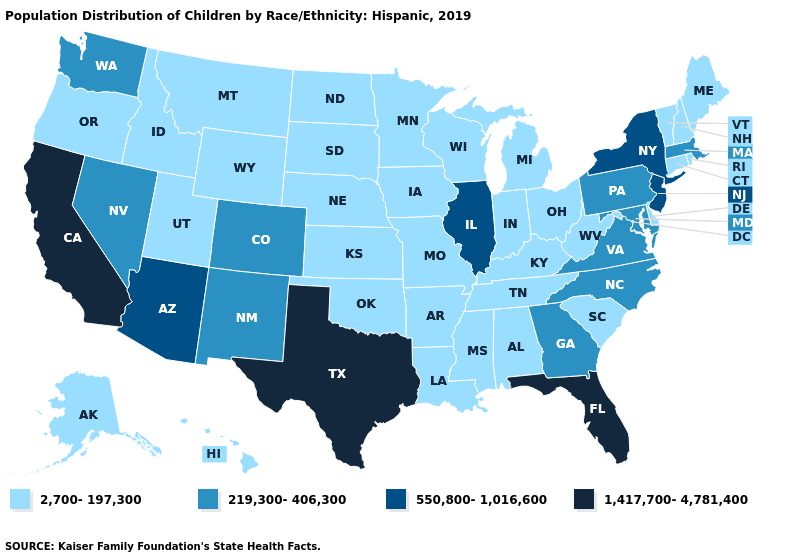Which states have the lowest value in the USA?
Write a very short answer. Alabama, Alaska, Arkansas, Connecticut, Delaware, Hawaii, Idaho, Indiana, Iowa, Kansas, Kentucky, Louisiana, Maine, Michigan, Minnesota, Mississippi, Missouri, Montana, Nebraska, New Hampshire, North Dakota, Ohio, Oklahoma, Oregon, Rhode Island, South Carolina, South Dakota, Tennessee, Utah, Vermont, West Virginia, Wisconsin, Wyoming. Does Missouri have the highest value in the MidWest?
Write a very short answer. No. What is the value of Idaho?
Write a very short answer. 2,700-197,300. Does Florida have the highest value in the USA?
Write a very short answer. Yes. What is the highest value in states that border New Mexico?
Quick response, please. 1,417,700-4,781,400. Among the states that border Virginia , does North Carolina have the highest value?
Write a very short answer. Yes. Does Colorado have a higher value than Missouri?
Be succinct. Yes. Among the states that border Iowa , does South Dakota have the highest value?
Short answer required. No. Name the states that have a value in the range 219,300-406,300?
Write a very short answer. Colorado, Georgia, Maryland, Massachusetts, Nevada, New Mexico, North Carolina, Pennsylvania, Virginia, Washington. What is the highest value in the USA?
Short answer required. 1,417,700-4,781,400. Which states have the highest value in the USA?
Quick response, please. California, Florida, Texas. Among the states that border Kansas , does Missouri have the highest value?
Give a very brief answer. No. What is the value of Michigan?
Short answer required. 2,700-197,300. Does the first symbol in the legend represent the smallest category?
Keep it brief. Yes. Does Mississippi have the same value as North Carolina?
Quick response, please. No. 